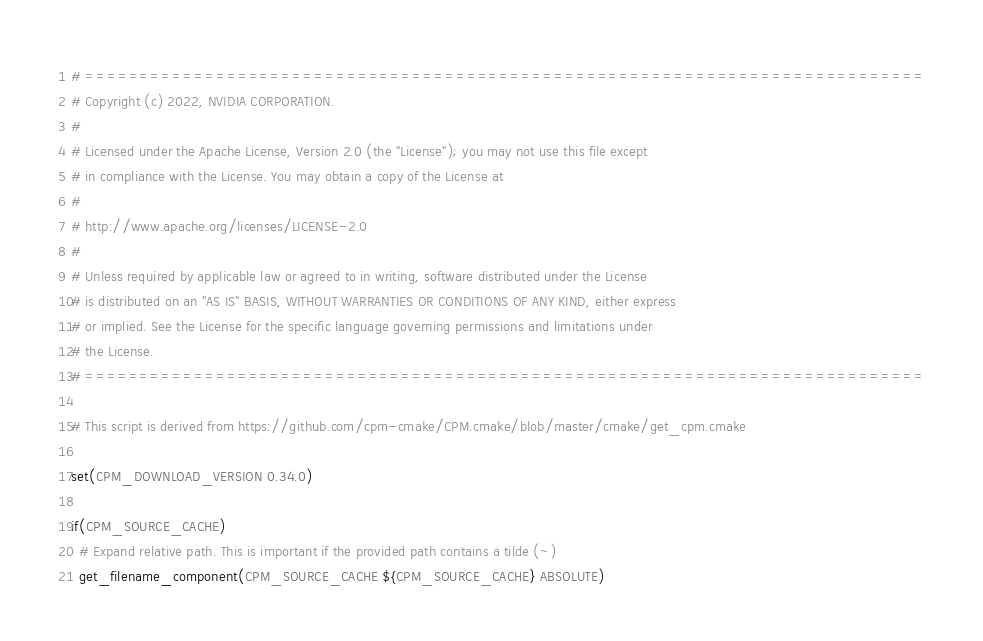Convert code to text. <code><loc_0><loc_0><loc_500><loc_500><_CMake_># =============================================================================
# Copyright (c) 2022, NVIDIA CORPORATION.
#
# Licensed under the Apache License, Version 2.0 (the "License"); you may not use this file except
# in compliance with the License. You may obtain a copy of the License at
#
# http://www.apache.org/licenses/LICENSE-2.0
#
# Unless required by applicable law or agreed to in writing, software distributed under the License
# is distributed on an "AS IS" BASIS, WITHOUT WARRANTIES OR CONDITIONS OF ANY KIND, either express
# or implied. See the License for the specific language governing permissions and limitations under
# the License.
# =============================================================================

# This script is derived from https://github.com/cpm-cmake/CPM.cmake/blob/master/cmake/get_cpm.cmake

set(CPM_DOWNLOAD_VERSION 0.34.0)

if(CPM_SOURCE_CACHE)
  # Expand relative path. This is important if the provided path contains a tilde (~)
  get_filename_component(CPM_SOURCE_CACHE ${CPM_SOURCE_CACHE} ABSOLUTE)</code> 